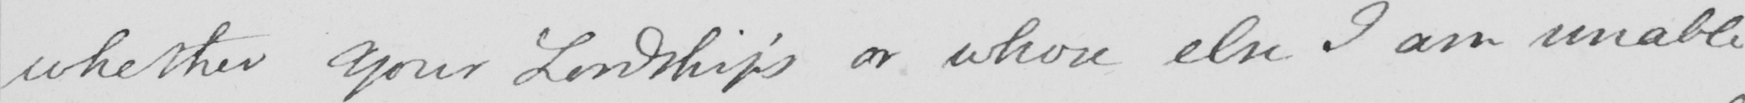Can you tell me what this handwritten text says? whether your Lordship ' s or whose else I am unable 